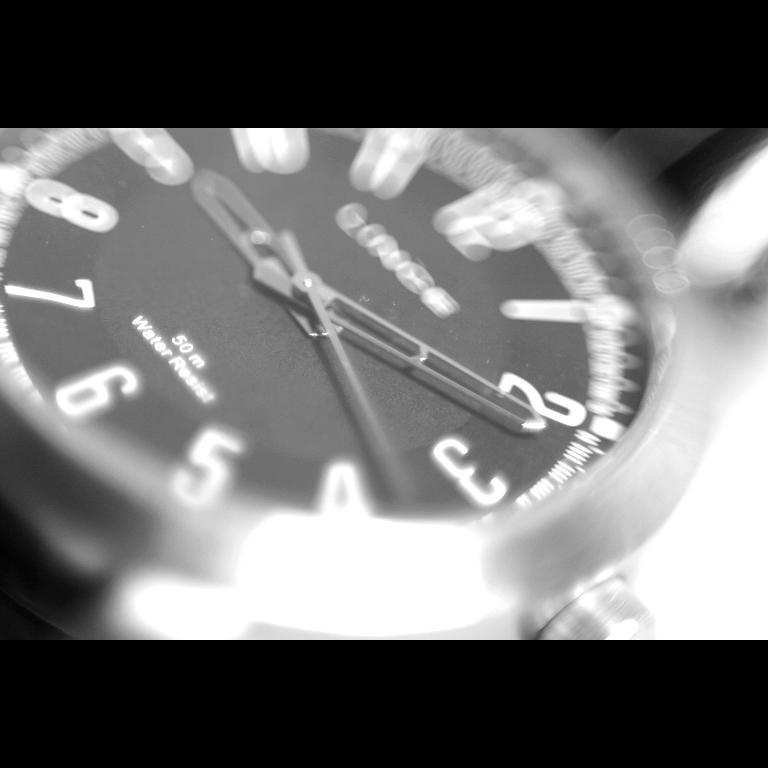<image>
Offer a succinct explanation of the picture presented. A watch with a black face showing the time of 9:11 